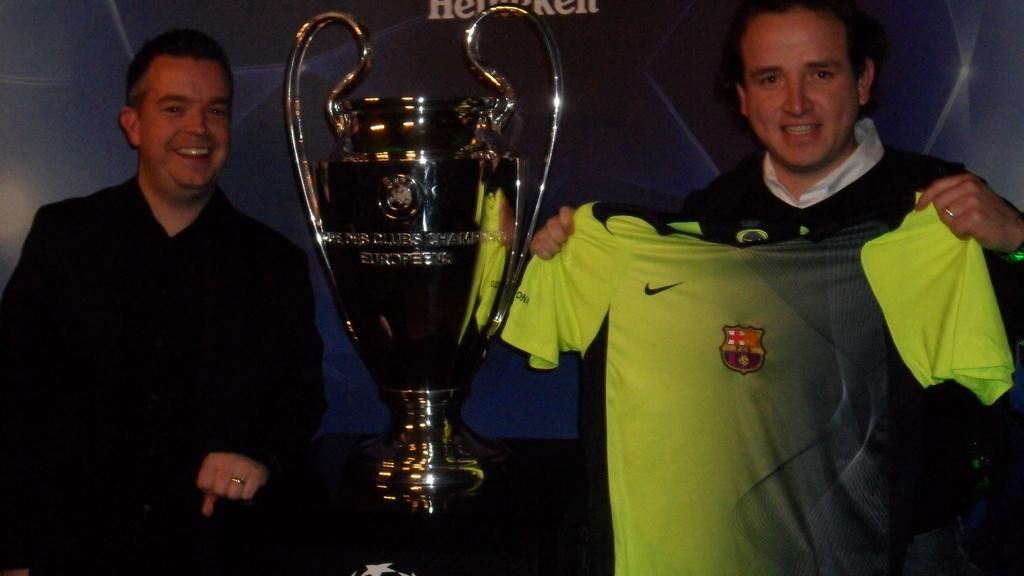What is the person in the image holding? The person is holding a shirt in the image. How does the person holding the shirt appear to feel? The person is smiling, which suggests they are happy or content. Can you describe the other person in the image? There is another person in the image, and they are also smiling. What object can be seen on a table in the image? There is a cup on a table in the image. What type of bear can be seen interacting with the cup on the table in the image? There is no bear present in the image; it features two people and a cup on a table. Is there any sleet visible in the image? There is no mention of sleet or any weather conditions in the provided facts, so it cannot be determined from the image. 